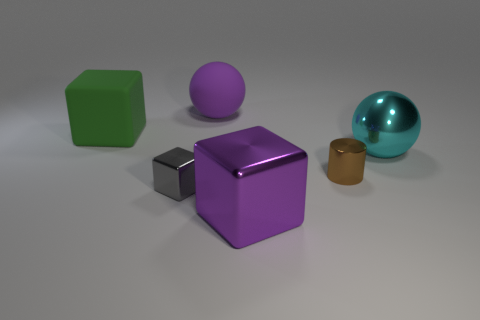What materials are visible in the objects displayed? The objects in the image are made from various materials; the green and purple cubes appear to have a matte, possibly plastic finish, while the cylinder and the smaller cube look metallic. The sphere and shiny blue object have a reflective surface that suggests they might be made of polished metal or glass. Are there any objects that particularly stand out due to their color or texture? The shiny turquoise sphere stands out due to its reflective, smooth surface and vibrant color, contrasting sharply with the matte textures and more subdued shades of the other objects. 